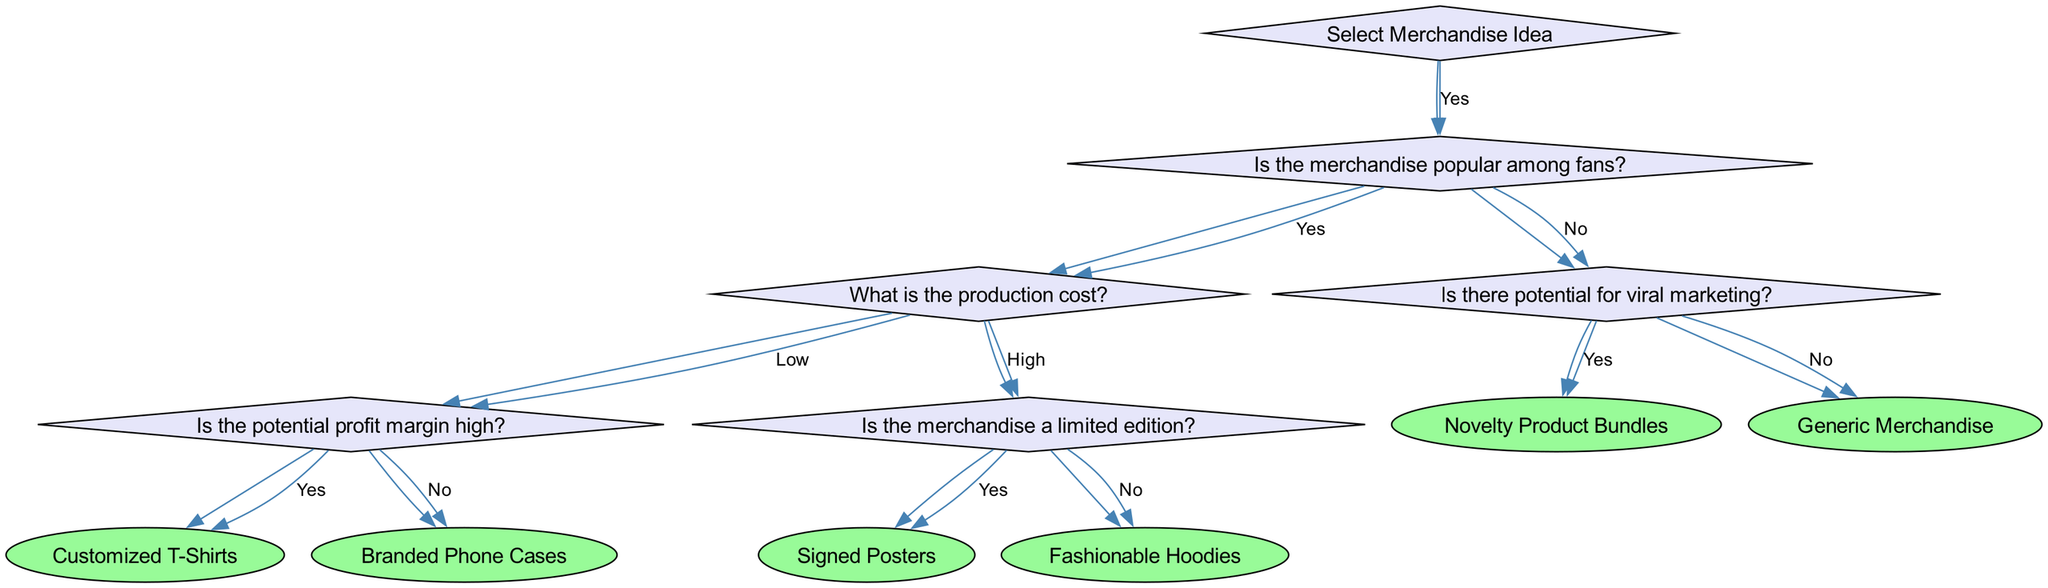What is the first question in the decision tree? The first question in the decision tree is about selecting a merchandise idea. It serves as the root of the decision tree and prompts further inquiries.
Answer: Select Merchandise Idea How many items are derived from the 'yes' path of the first question? Following the 'yes' choice from the first question, there are four distinct items that can result from the decision tree: Customized T-Shirts, Branded Phone Cases, Signed Posters, and Fashionable Hoodies.
Answer: Four What item results if the merchandise is popular and the production cost is high with limited edition? In this scenario, if the merchandise is popular, has a high production cost, and is a limited edition, the resulting item is Signed Posters.
Answer: Signed Posters What happens if the merchandise is not popular and has potential for viral marketing? If merchandise is determined to be unpopular but has potential for viral marketing, the outcome of the decision tree leads to the item Generic Merchandise.
Answer: Generic Merchandise What is the specific condition to get Branded Phone Cases? To arrive at Branded Phone Cases, the conditions are that the merchandise must be popular among fans, have a low production cost, and a potential profit margin that is not high.
Answer: Low production cost and not high profit margin Which merchandise is suggested if the production cost is high and it's not limited edition? If the production cost is high and the merchandise is not a limited edition, the item suggested would be Fashionable Hoodies.
Answer: Fashionable Hoodies What do you get if the merchandise idea is popular but there's no potential for viral marketing? In this case, if the merchandise is popular but lacks viral marketing potential, the decision tree leads to Generic Merchandise.
Answer: Generic Merchandise What type of decision is at the root of this diagram? The root of this decision tree involves making a choice regarding the selection of merchandise ideas based on various evaluations.
Answer: Merchandise selection 